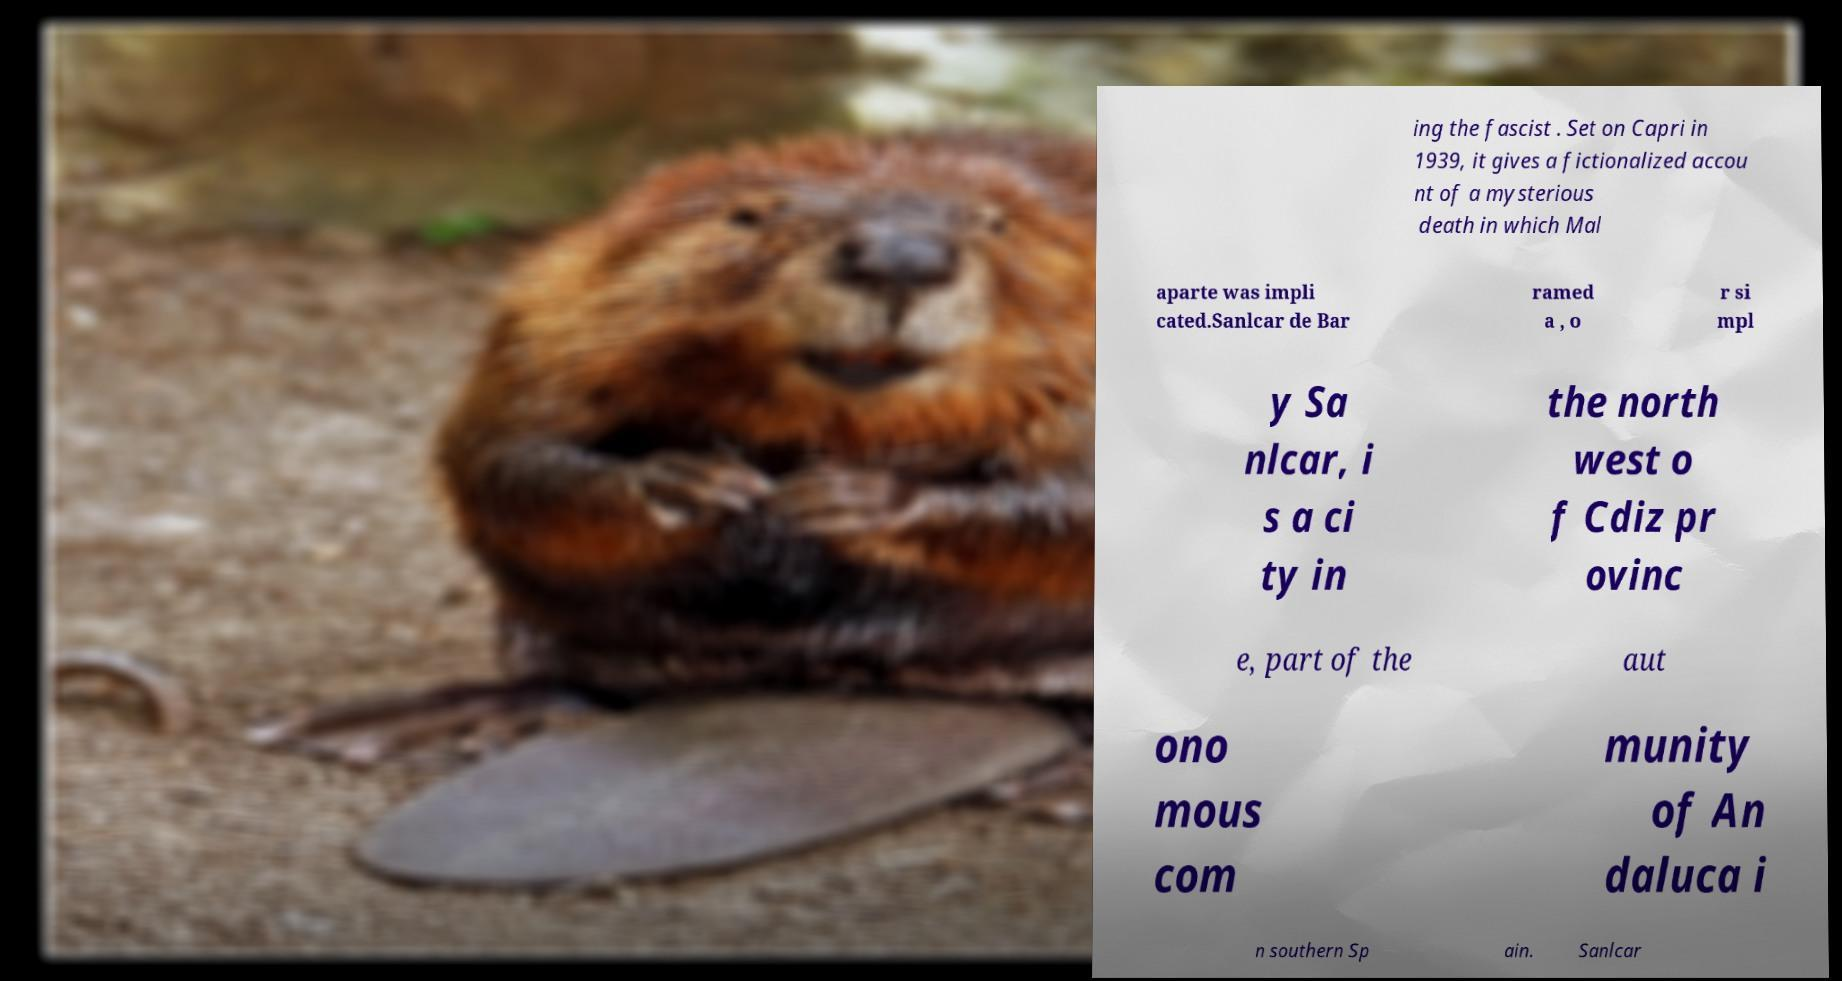Can you read and provide the text displayed in the image?This photo seems to have some interesting text. Can you extract and type it out for me? ing the fascist . Set on Capri in 1939, it gives a fictionalized accou nt of a mysterious death in which Mal aparte was impli cated.Sanlcar de Bar ramed a , o r si mpl y Sa nlcar, i s a ci ty in the north west o f Cdiz pr ovinc e, part of the aut ono mous com munity of An daluca i n southern Sp ain. Sanlcar 